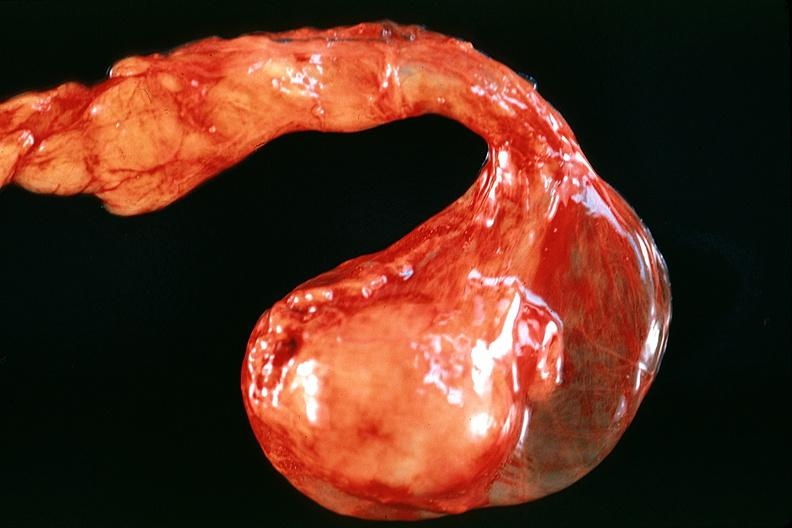what is present?
Answer the question using a single word or phrase. Male reproductive 